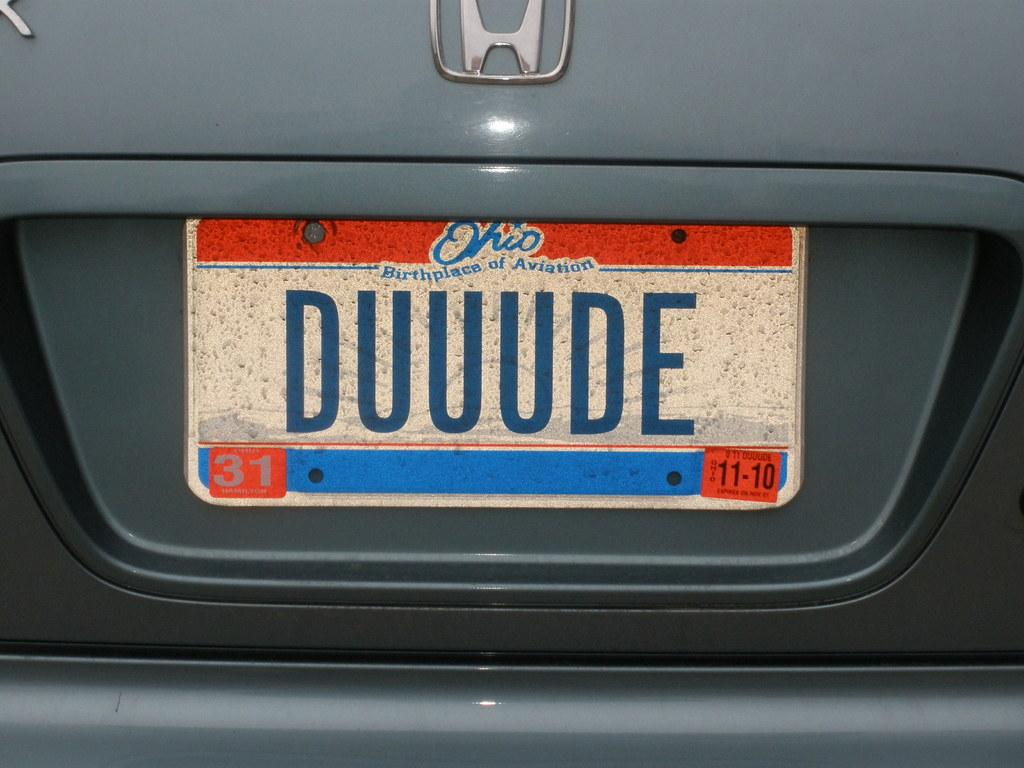<image>
Provide a brief description of the given image. A Honda with an Ohio license plate reads "DUUUDE" 